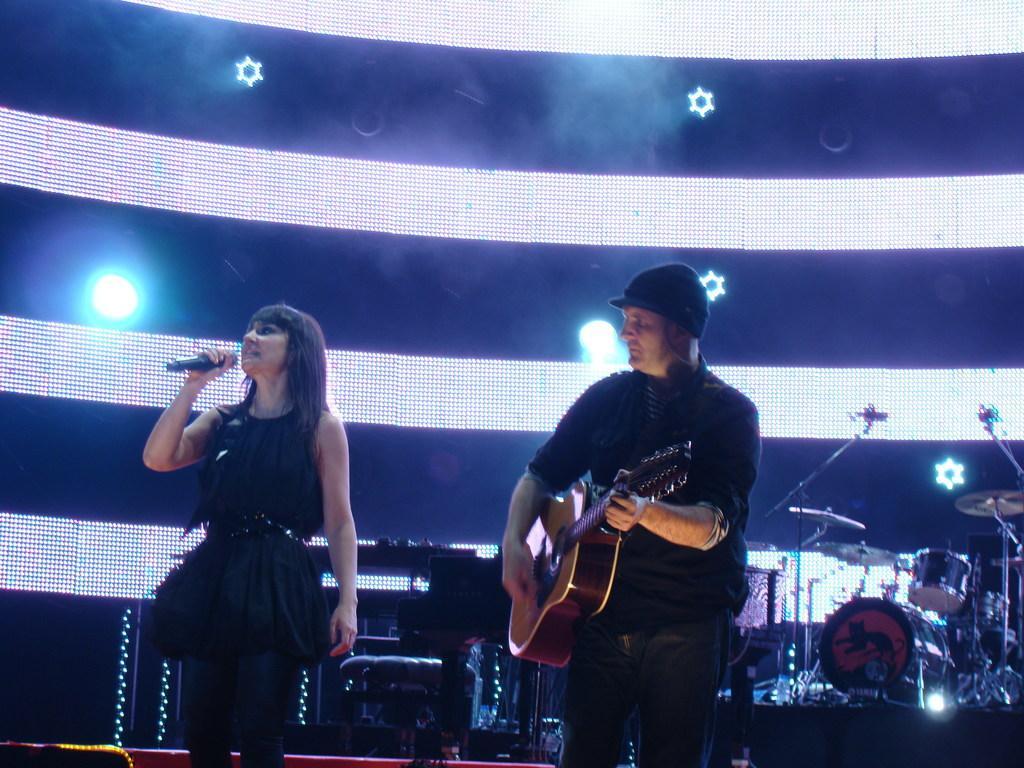Can you describe this image briefly? On the background we can see colorful lights. We can see one man standing and playing guitar. We can see one woman in a black dress, holding a mike and singing. On the background we can see drums, cymbals and mike's. 